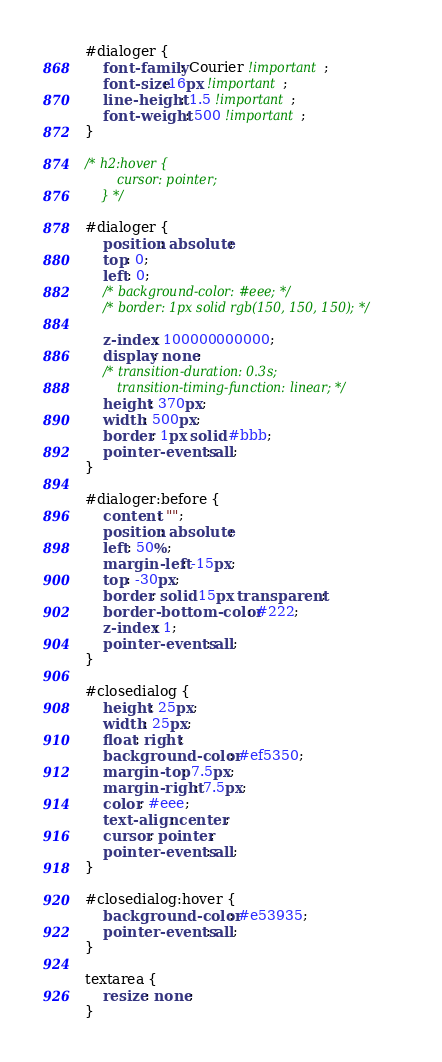Convert code to text. <code><loc_0><loc_0><loc_500><loc_500><_CSS_>#dialoger {
    font-family: Courier !important;
    font-size:16px !important;
    line-height: 1.5 !important;
    font-weight: 500 !important;
}

/* h2:hover {
        cursor: pointer;
    } */

#dialoger {
    position: absolute;
    top: 0;
    left: 0;
    /* background-color: #eee; */
    /* border: 1px solid rgb(150, 150, 150); */

    z-index: 100000000000;
    display: none;
    /* transition-duration: 0.3s;
        transition-timing-function: linear; */
    height: 370px;
    width: 500px;
    border: 1px solid #bbb;
    pointer-events: all;
}

#dialoger:before {
    content: "";
    position: absolute;
    left: 50%;
    margin-left: -15px;
    top: -30px;
    border: solid 15px transparent;
    border-bottom-color: #222;
    z-index: 1;
    pointer-events: all;
}

#closedialog {
    height: 25px;
    width: 25px;
    float: right;
    background-color: #ef5350;
    margin-top: 7.5px;
    margin-right: 7.5px;
    color: #eee;
    text-align: center;
    cursor: pointer;
    pointer-events: all;
}

#closedialog:hover {
    background-color: #e53935;
    pointer-events: all;
}

textarea {
    resize: none;
}</code> 